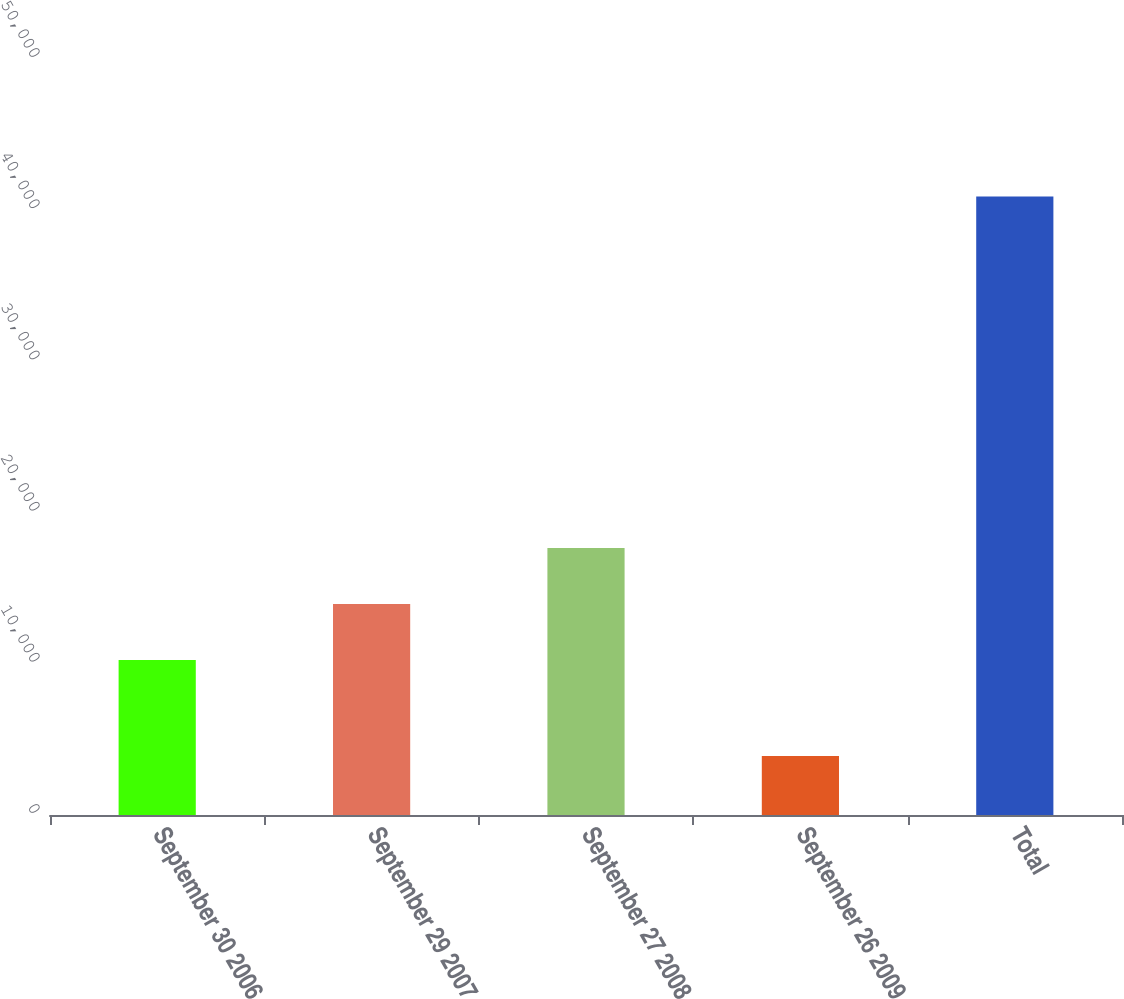Convert chart to OTSL. <chart><loc_0><loc_0><loc_500><loc_500><bar_chart><fcel>September 30 2006<fcel>September 29 2007<fcel>September 27 2008<fcel>September 26 2009<fcel>Total<nl><fcel>10255<fcel>13956.1<fcel>17657.2<fcel>3895<fcel>40906<nl></chart> 